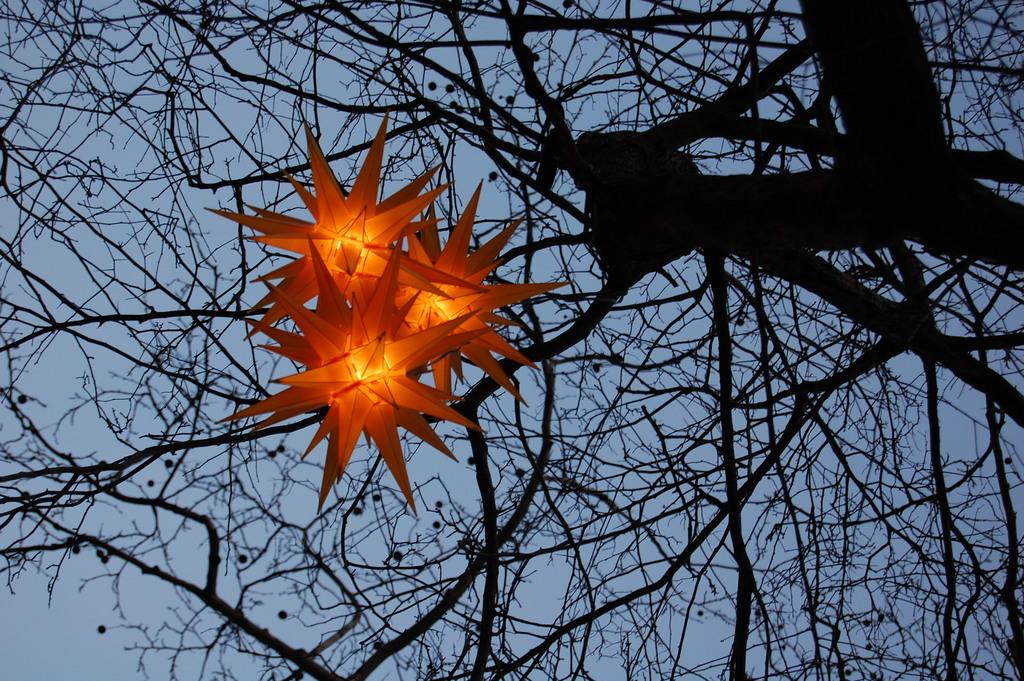What can be seen in the image that provides illumination? There are lights in the image. What type of tree is present in the image? There is a dry tree in the image. How many cats are sitting on the rail in the image? There are no cats or rails present in the image. 